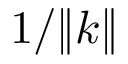Convert formula to latex. <formula><loc_0><loc_0><loc_500><loc_500>1 / \| k \|</formula> 